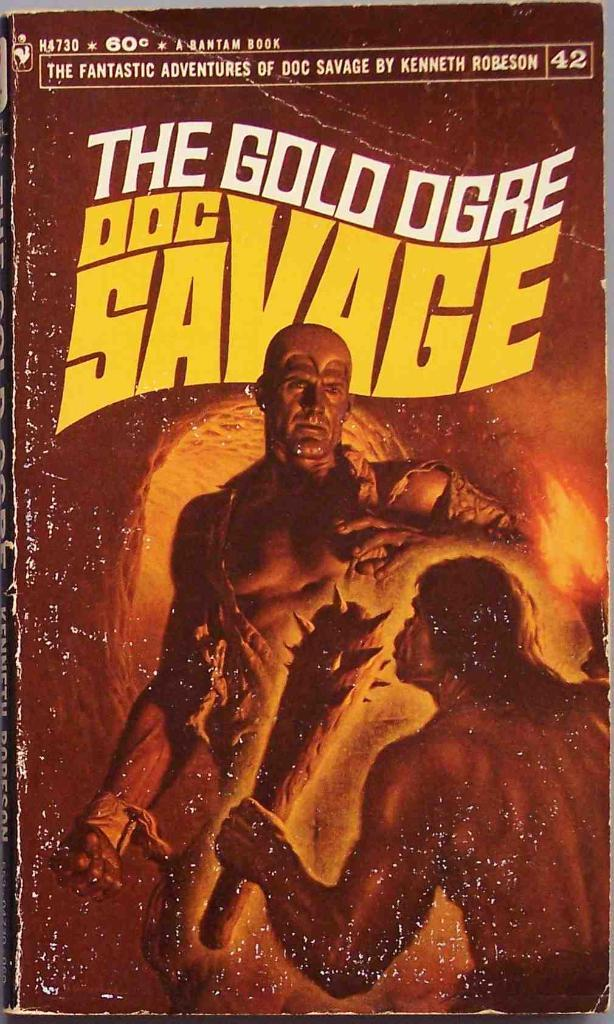<image>
Describe the image concisely. A paper back book titled The Gold Ogre Doc Savage. 